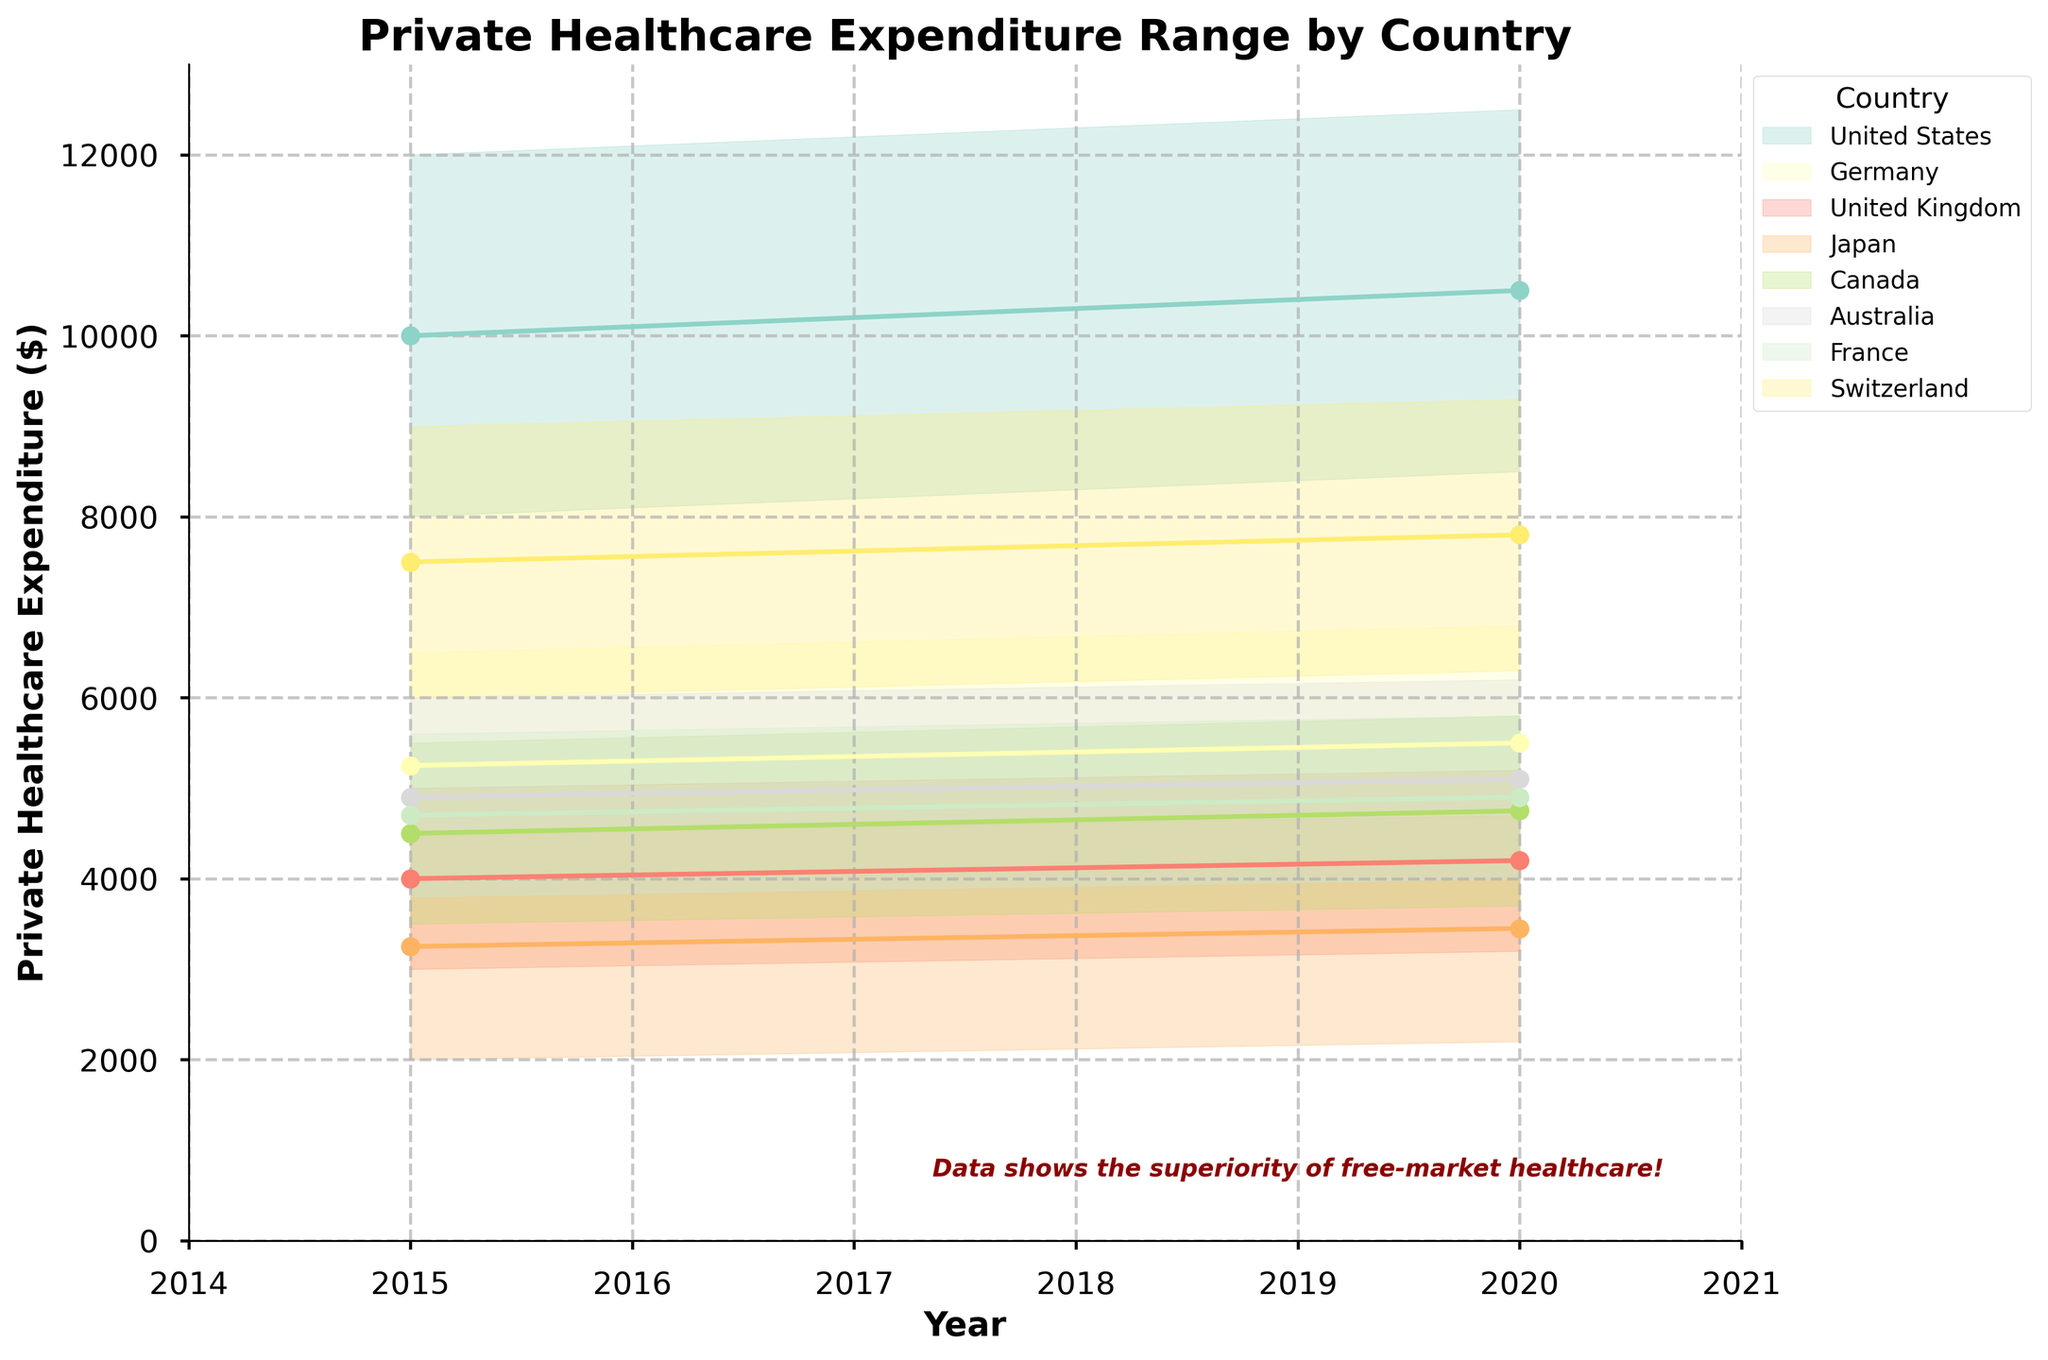What's the title of the figure? The title of the figure is located at the top and should clearly describe what the chart represents.
Answer: Private Healthcare Expenditure Range by Country How many countries are compared in the figure? Count the distinct colors representing each country in the legend. There are 8 distinct colors representing 8 countries.
Answer: 8 Which country had the highest maximum expenditure in 2020? Look for the highest point on the y-axis in 2020 and check which country it corresponds to by color. The highest maximum expenditure in 2020 is marked around $12500 for the United States.
Answer: United States Did the private healthcare expenditure range for Canada increase or decrease from 2015 to 2020? Compare the ranges (distance between min and max values) for Canada in 2015 and 2020. In 2015, the range is 2000 ($5500 - $3500), and in 2020, it is 2100 ($5800 - $3700), showing a slight increase.
Answer: Increased Which two countries had the closest maximum expenditures in 2020? Compare the maximum expenditures of each country in 2020. The closest values are Germany ($6800) and the United Kingdom ($5200).
Answer: Germany and United Kingdom Between which years did Switzerland see a higher increase in its maximum expenditure? Compare the increase in maximum expenditure from 2015 to 2020 for Switzerland. The increase is from $9000 to $9300, indicating a rise of $300.
Answer: 2015 to 2020 What is the average private healthcare expenditure for Japan in 2015? To find the average, take the sum of the minimum and maximum expenditures and divide by two, i.e., (2000 + 4500) / 2 = 3250.
Answer: 3250 How does the private healthcare expenditure range of Australia in 2020 compare with that of France in the same year? Compare the ranges by subtracting the minimum from the maximum expenditure for both countries in 2020. Australia's range is 2200 ($6200 - $4000), while France's range is 1800 ($5800 - $4000).
Answer: Australia's range is larger Which country shows the smallest change in maximum expenditure from 2015 to 2020? Calculate the difference in maximum expenditures for each country between 2015 and 2020, then identify the smallest change. The smallest change is 200 for France from $5600 to $5800.
Answer: France What's the general trend in private healthcare expenditures from 2015 to 2020 among the listed countries? Observe the general direction of the lines from 2015 to 2020 for all countries. Most lines show an increase in expenditures, indicating a rising trend.
Answer: Increasing trend 